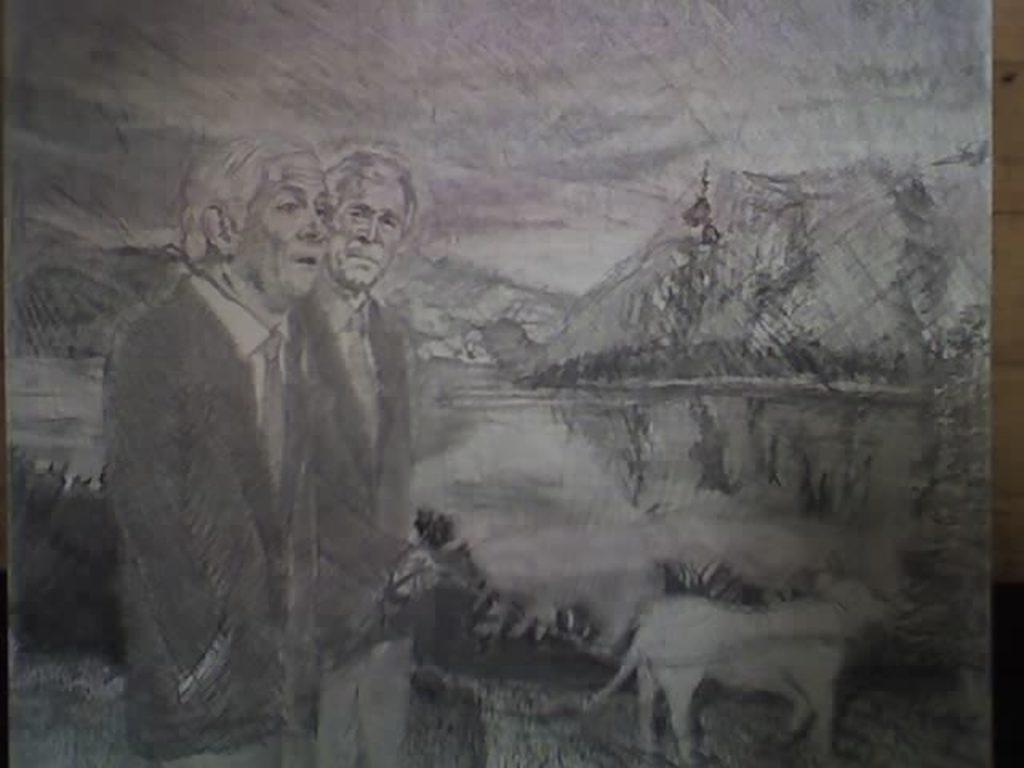What is the main subject of the drawing in the image? The main subject of the drawing in the image is people. What geographical feature is included in the drawing? The drawing includes a mountain. What other type of subject is depicted in the drawing? There is an animal depicted at the bottom of the image. What is the distance between the people and the jelly in the image? There is no jelly present in the image, so it is not possible to determine the distance between the people and jelly. 